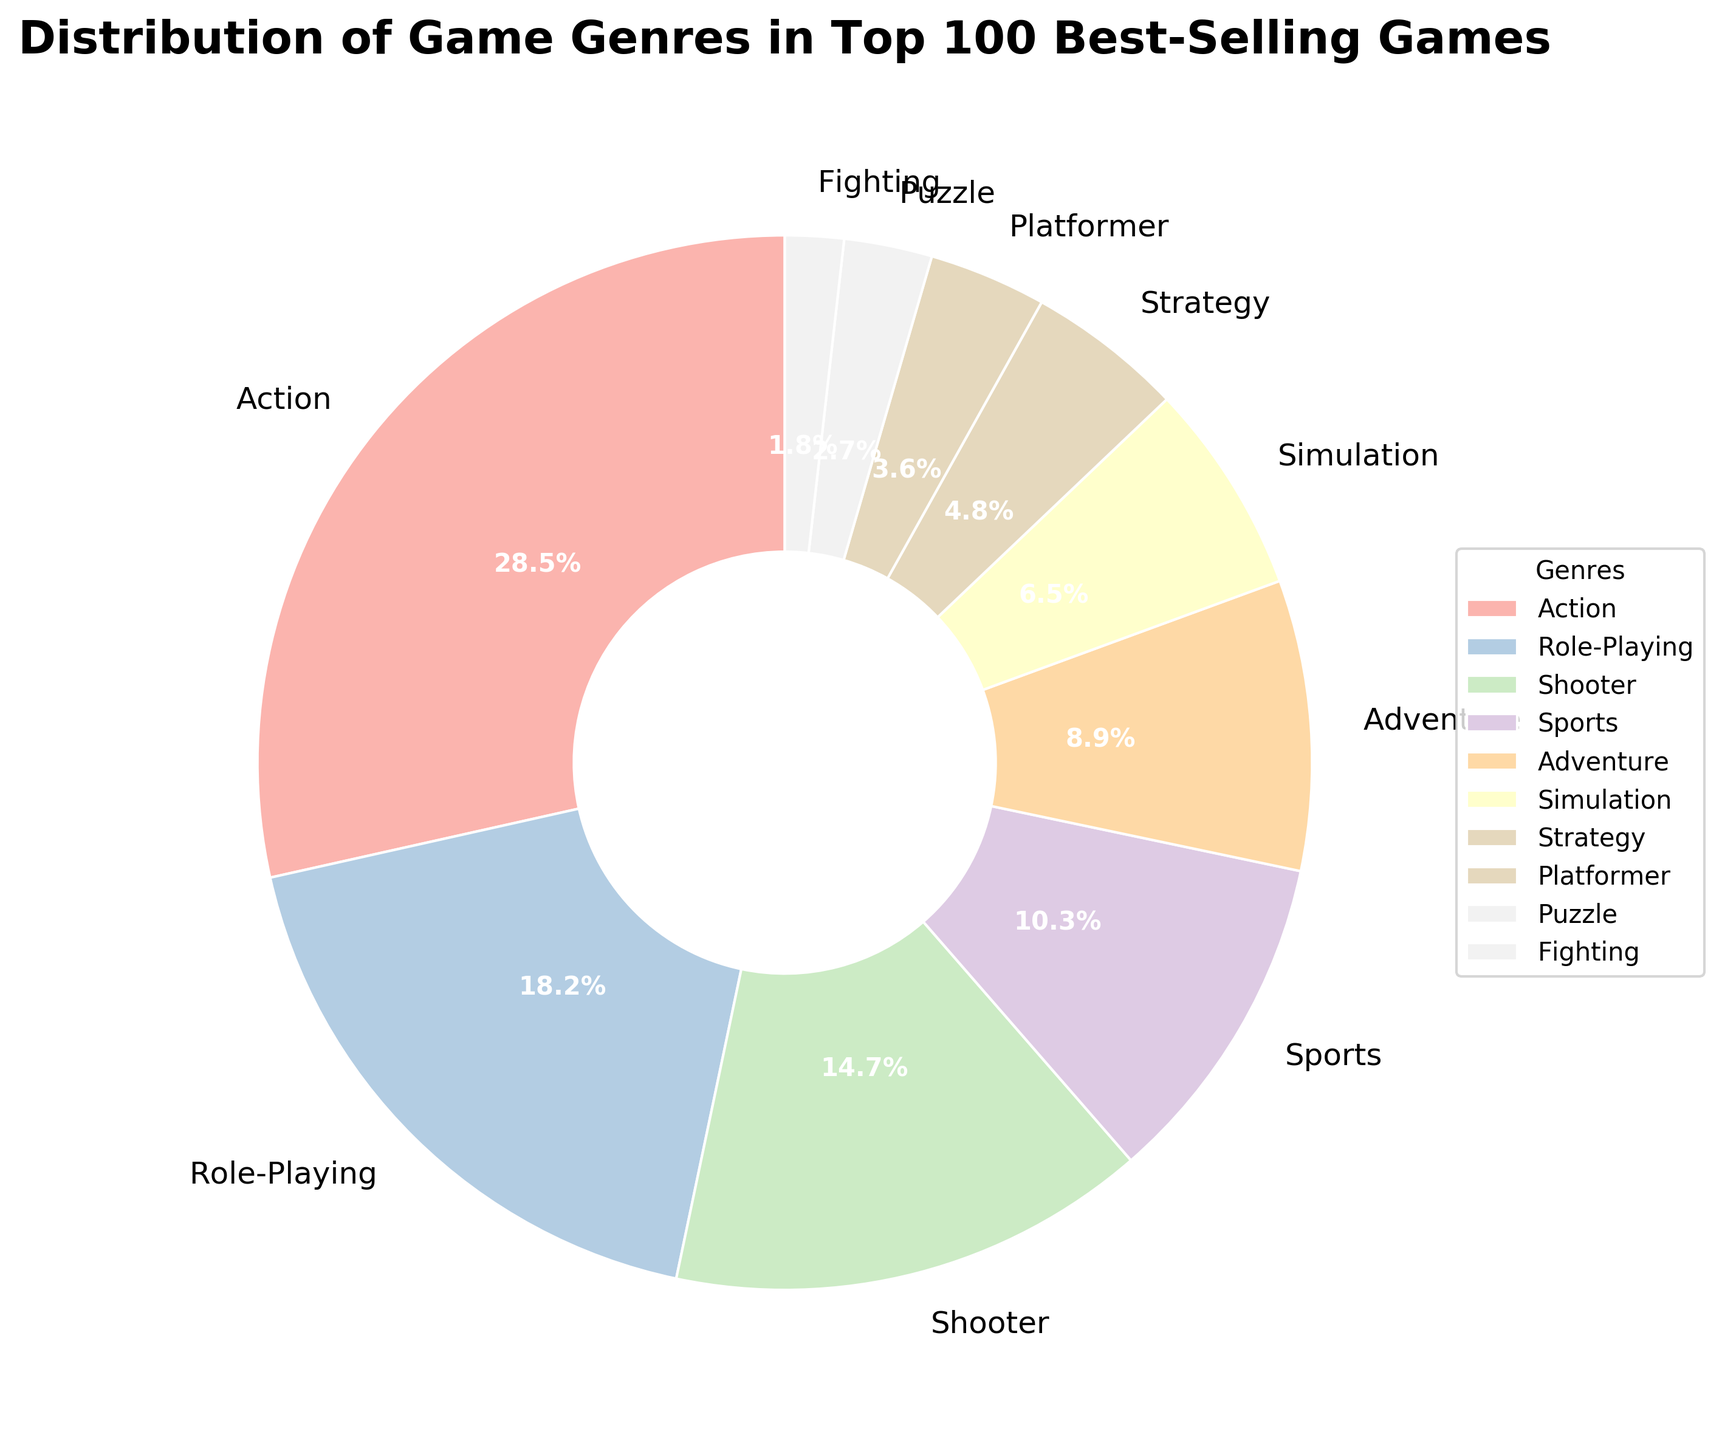What's the most popular game genre among the top 100 best-selling games? The figure's title tells us it shows the distribution of game genres in the top 100 best-selling games. The largest wedge has a label of 'Action' with a percentage of 28.5%. Therefore, Action is the most popular genre.
Answer: Action Which game genre has the lowest percentage of the top 100 best-selling games? The smallest wedge in the pie chart is labeled 'Fighting', with a percentage of 1.8%. This makes Fighting the genre with the lowest percentage.
Answer: Fighting How much more popular is the Action genre than the Sports genre? The Action genre accounts for 28.5% of the pie chart, and the Sports genre accounts for 10.3%. The difference in their popularity is 28.5% - 10.3% = 18.2%.
Answer: 18.2% What is the combined percentage of the Role-Playing and Simulation genres? The Role-Playing genre accounts for 18.2% and the Simulation genre accounts for 6.5%. Their combined percentage is 18.2% + 6.5% = 24.7%.
Answer: 24.7% Is the percentage of the Shooter genre greater than that of Adventure? The Shooter genre makes up 14.7% of the chart, while the Adventure genre makes up 8.9%. Since 14.7% is greater than 8.9%, the percentage of the Shooter genre is indeed greater than that of the Adventure genre.
Answer: Yes What percentage of the top 100 best-selling games are in genres other than Action, Role-Playing, and Shooter? Combined, the Action, Role-Playing, and Shooter genres make up 28.5% + 18.2% + 14.7% = 61.4%. The remaining percentage is 100% - 61.4% = 38.6%.
Answer: 38.6% Which genre has a slightly higher percentage: Adventure or Simulation? Adventure accounts for 8.9% of the pie chart, while Simulation accounts for 6.5%. Since 8.9% is greater than 6.5%, Adventure has the higher percentage.
Answer: Adventure Does the combined percentage of Platformer and Puzzle genres exceed that of the Sports genre? Platformer accounts for 3.6% and Puzzle accounts for 2.7%. Their combined percentage is 3.6% + 2.7% = 6.3%. The Sports genre alone accounts for 10.3%. Since 6.3% is less than 10.3%, the combined percentage of Platformer and Puzzle does not exceed that of the Sports genre.
Answer: No 